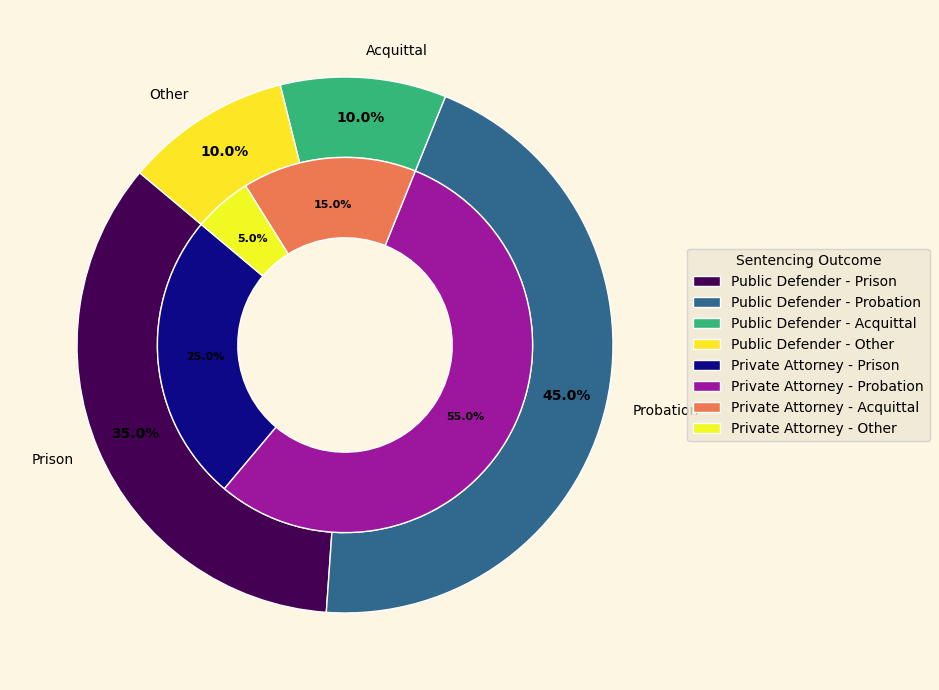What's the difference in percentage of prison sentences between Public Defenders and Private Attorneys? From the figure’s labels, Public Defenders have 35% in prison sentences and Private Attorneys have 25%. The difference is 35% - 25%.
Answer: 10% Which legal representation has a higher rate of probation sentences? Looking at the probation section of the chart, Public Defenders have 45% and Private Attorneys have 55%.
Answer: Private Attorneys What percentage of cases result in acquittal for Public Defenders compared to Private Attorneys? According to the figure, Public Defenders have a 10% acquittal rate and Private Attorneys have a 15% acquittal rate.
Answer: Public Defenders have 5% less In which outcome category do Public Defenders and Private Attorneys show the most significant percentage difference? The figure indicates the largest difference is in probation: 45% for Public Defenders and 55% for Private Attorneys, equating to a 10% difference.
Answer: Probation What's the combined percentage of acquittal and other outcomes for Private Attorneys? Sum the percentages for acquittal (15%) and other outcomes (5%) for Private Attorneys. 15% + 5% = 20%.
Answer: 20% Which sentencing outcome has the smallest difference between Public Defenders and Private Attorneys? By observing the visual chart data, the smallest difference is in the "Other" category, with Public Defenders at 10% and Private Attorneys at 5%, making a 5% difference.
Answer: Other What is the visual difference in ring size related to probation sentences between Public Defenders and Private Attorneys? The outer ring (Public Defenders) has a smaller section gap compared to the corresponding inner ring (Private Attorneys) for probation, indicating a lower percentage visually.
Answer: Public Defenders have a smaller section How does the proportion of acquittals compare visually between Public Defenders and Private Attorneys? The acquittal section for Private Attorneys appears slightly larger in the central ring compared to the outer ring for Public Defenders, indicating more acquittals with Private Attorneys.
Answer: Larger for Private Attorneys What's the total percentage of non-prison outcomes (probation, acquittal, and other) for Public Defenders? Sum the non-prison outcomes for Public Defenders: probation (45%), acquittal (10%), and other (10%). 45% + 10% + 10% = 65%.
Answer: 65% Which legal representation shows a higher percentage for 'Other' outcomes, and by how much? Public Defenders show 10% and Private Attorneys show 5% for 'Other' outcomes. The difference is 10% - 5%.
Answer: Public Defenders by 5% 